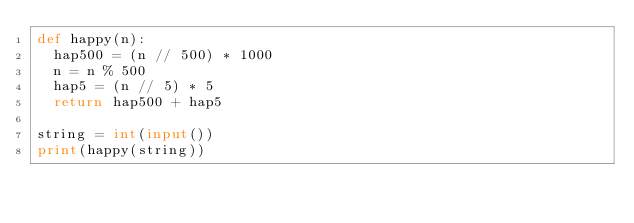Convert code to text. <code><loc_0><loc_0><loc_500><loc_500><_Python_>def happy(n):
  hap500 = (n // 500) * 1000
  n = n % 500
  hap5 = (n // 5) * 5
  return hap500 + hap5

string = int(input())
print(happy(string))</code> 